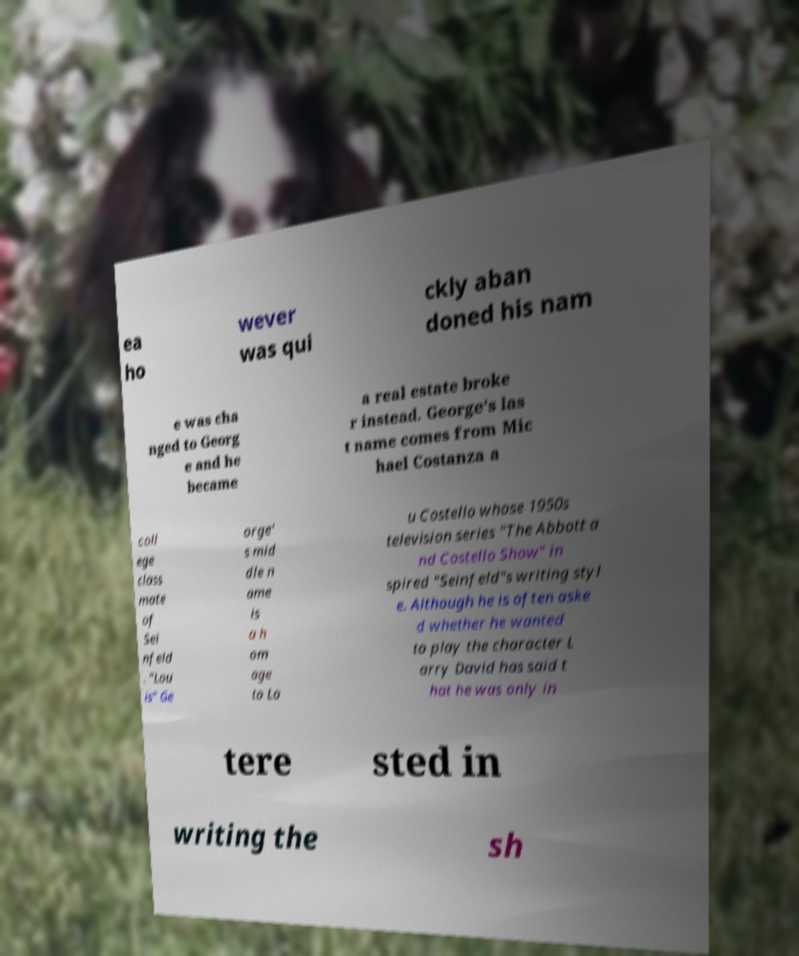Please read and relay the text visible in this image. What does it say? ea ho wever was qui ckly aban doned his nam e was cha nged to Georg e and he became a real estate broke r instead. George's las t name comes from Mic hael Costanza a coll ege class mate of Sei nfeld . "Lou is" Ge orge' s mid dle n ame is a h om age to Lo u Costello whose 1950s television series "The Abbott a nd Costello Show" in spired "Seinfeld"s writing styl e. Although he is often aske d whether he wanted to play the character L arry David has said t hat he was only in tere sted in writing the sh 